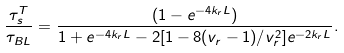Convert formula to latex. <formula><loc_0><loc_0><loc_500><loc_500>\frac { \tau _ { s } ^ { T } } { \tau _ { B L } } = \frac { ( 1 - e ^ { - 4 k _ { r } L } ) } { 1 + e ^ { - 4 k _ { r } L } - 2 [ 1 - 8 ( v _ { r } - 1 ) / v _ { r } ^ { 2 } ] e ^ { - 2 k _ { r } L } } .</formula> 